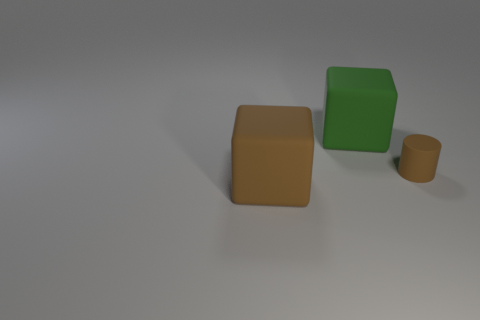Add 3 tiny brown rubber objects. How many objects exist? 6 Add 3 tiny matte things. How many tiny matte things are left? 4 Add 2 rubber cubes. How many rubber cubes exist? 4 Subtract 0 purple cylinders. How many objects are left? 3 Subtract all cylinders. How many objects are left? 2 Subtract all rubber cubes. Subtract all green matte things. How many objects are left? 0 